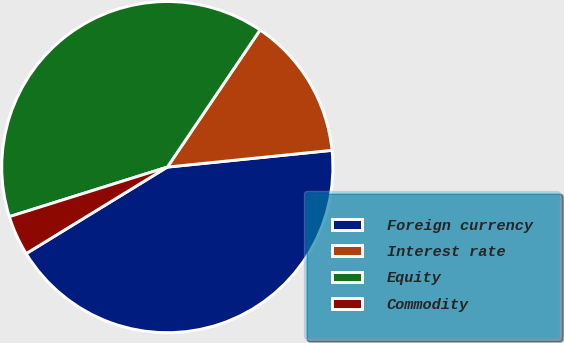<chart> <loc_0><loc_0><loc_500><loc_500><pie_chart><fcel>Foreign currency<fcel>Interest rate<fcel>Equity<fcel>Commodity<nl><fcel>42.87%<fcel>13.92%<fcel>39.31%<fcel>3.91%<nl></chart> 